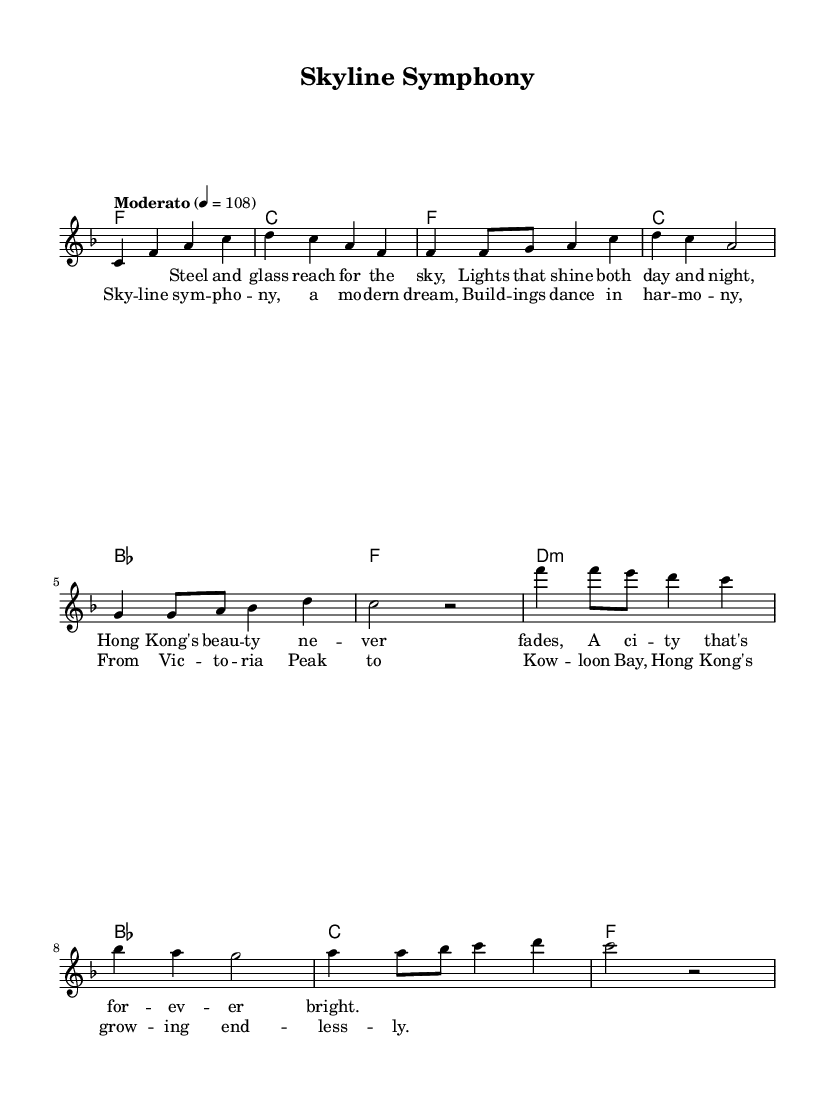What is the key signature of this music? The key signature is F major, indicated by one flat.
Answer: F major What is the time signature of this music? The time signature is 4/4, shown at the beginning of the score.
Answer: 4/4 What is the tempo marking for this piece? The tempo marking states "Moderato" with a metronome marking of 108.
Answer: Moderato 108 How many measures are in the verse section? The verse section consists of four measures, counting from the first verse to the end of the second line of lyrics.
Answer: 4 What is the highest note in the melody? The highest note is C, which appears in several places throughout the piece.
Answer: C What is the harmonic progression in the chorus? The harmonic progression in the chorus follows D minor, B flat, C, and F. This is determined by analyzing the chord symbols in the chorus section.
Answer: D minor, B flat, C, F What theme is expressed in the lyrics of this song? The lyrics express admiration for Hong Kong's skyline and urban beauty. This is derived from the lyrical content describing the city's vibrant lights and modern architectural landscape.
Answer: Hong Kong's skyline and urban beauty 